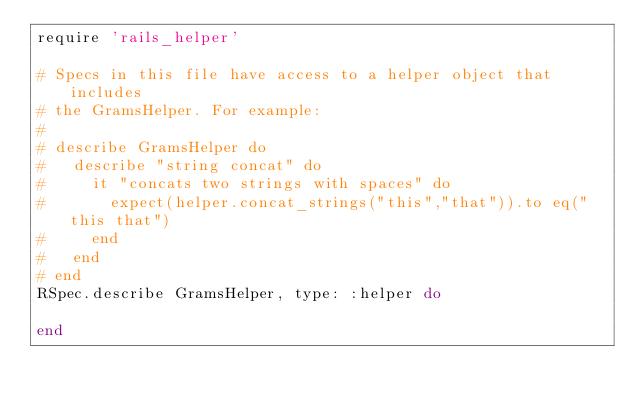Convert code to text. <code><loc_0><loc_0><loc_500><loc_500><_Ruby_>require 'rails_helper'

# Specs in this file have access to a helper object that includes
# the GramsHelper. For example:
#
# describe GramsHelper do
#   describe "string concat" do
#     it "concats two strings with spaces" do
#       expect(helper.concat_strings("this","that")).to eq("this that")
#     end
#   end
# end
RSpec.describe GramsHelper, type: :helper do
  
end
</code> 